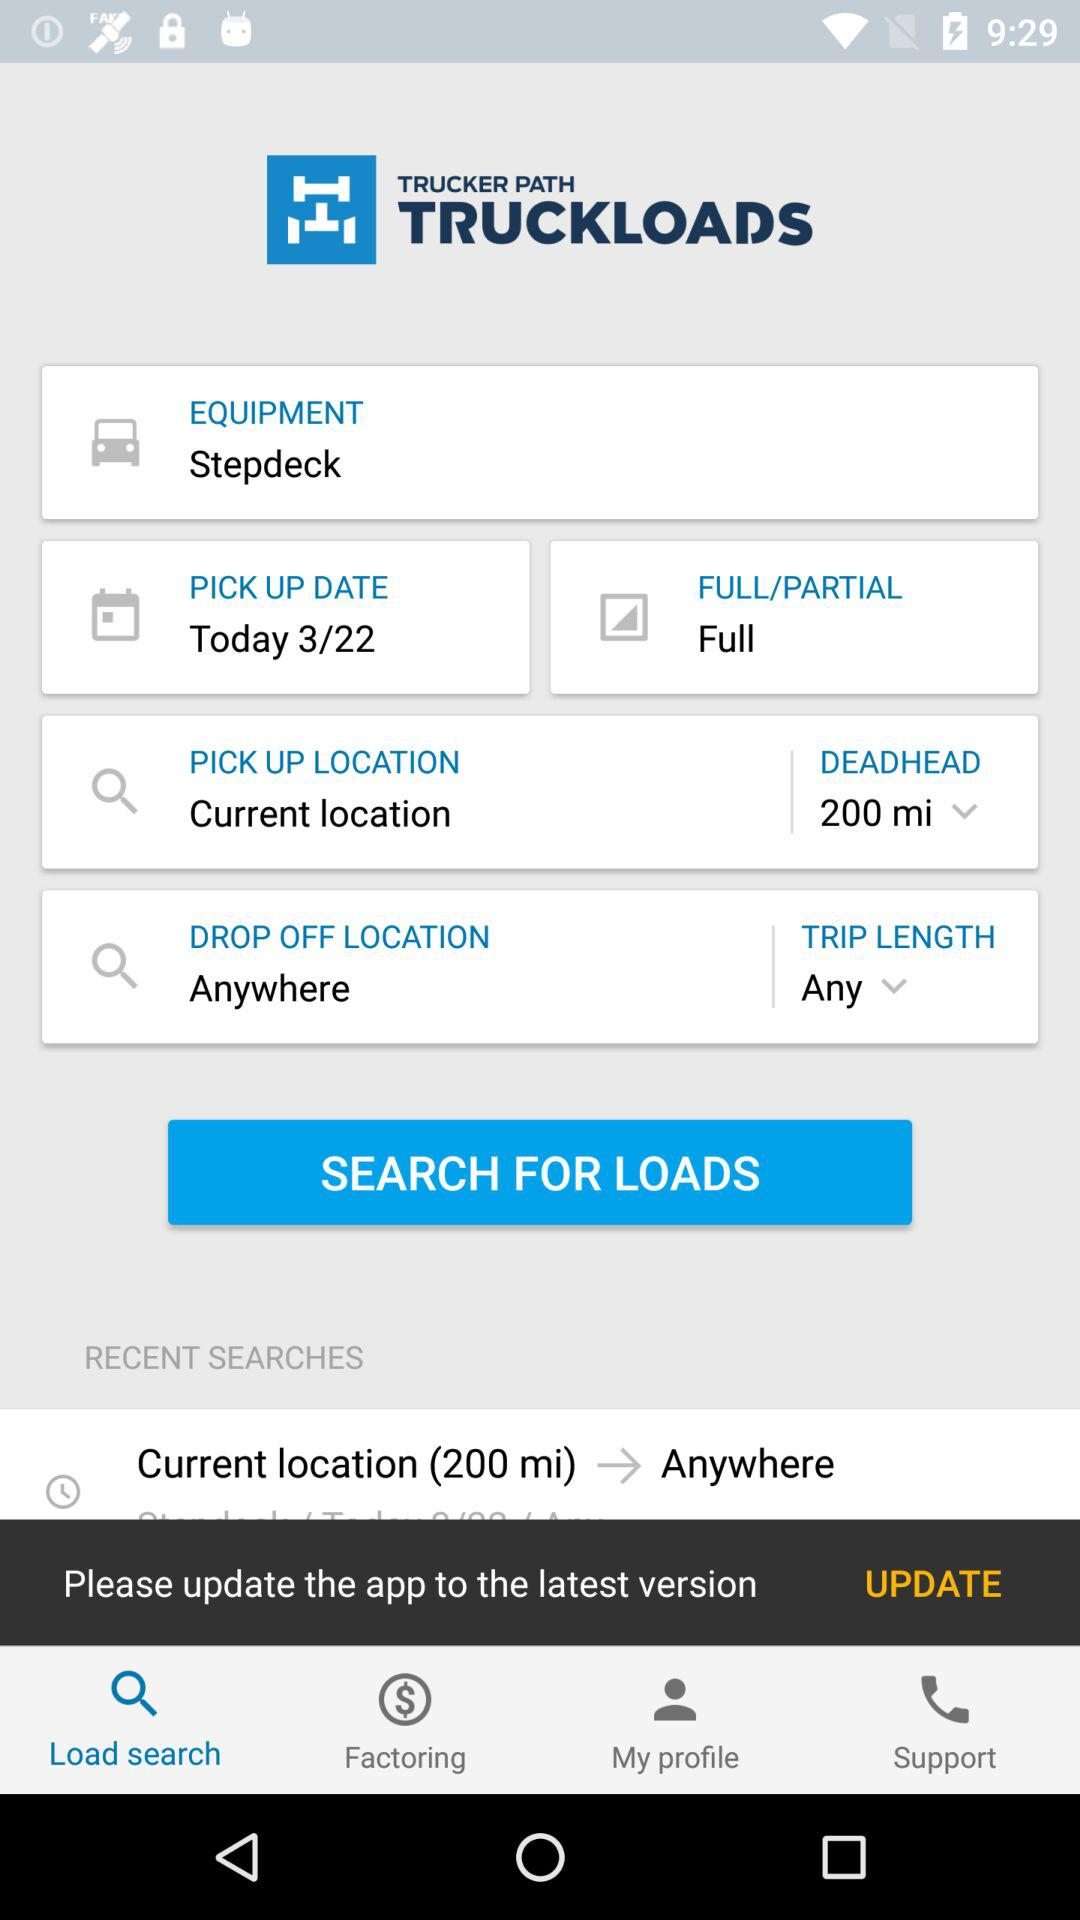What is the distance of the deadhead? The distance is 200 miles. 